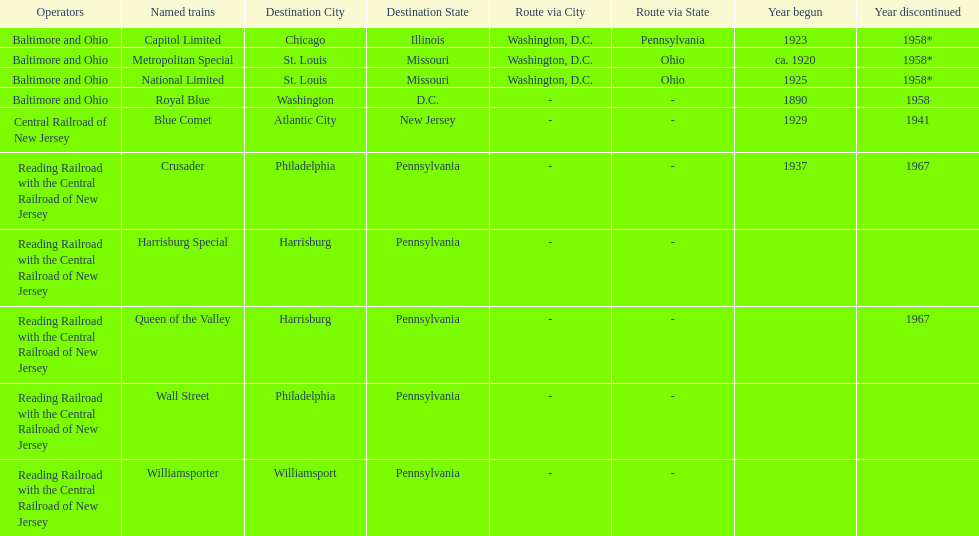Which other traine, other than wall street, had philadelphia as a destination? Crusader. 